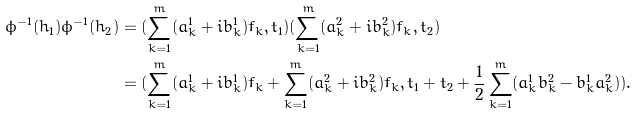Convert formula to latex. <formula><loc_0><loc_0><loc_500><loc_500>\phi ^ { - 1 } ( h _ { 1 } ) \phi ^ { - 1 } ( h _ { 2 } ) & = ( \sum ^ { m } _ { k = 1 } ( a ^ { 1 } _ { k } + i b ^ { 1 } _ { k } ) f _ { k } , t _ { 1 } ) ( \sum ^ { m } _ { k = 1 } ( a ^ { 2 } _ { k } + i b ^ { 2 } _ { k } ) f _ { k } , t _ { 2 } ) \\ & = ( \sum ^ { m } _ { k = 1 } ( a ^ { 1 } _ { k } + i b ^ { 1 } _ { k } ) f _ { k } + \sum ^ { m } _ { k = 1 } ( a ^ { 2 } _ { k } + i b ^ { 2 } _ { k } ) f _ { k } , t _ { 1 } + t _ { 2 } + \frac { 1 } { 2 } \sum ^ { m } _ { k = 1 } ( a ^ { 1 } _ { k } b ^ { 2 } _ { k } - b ^ { 1 } _ { k } a ^ { 2 } _ { k } ) ) .</formula> 